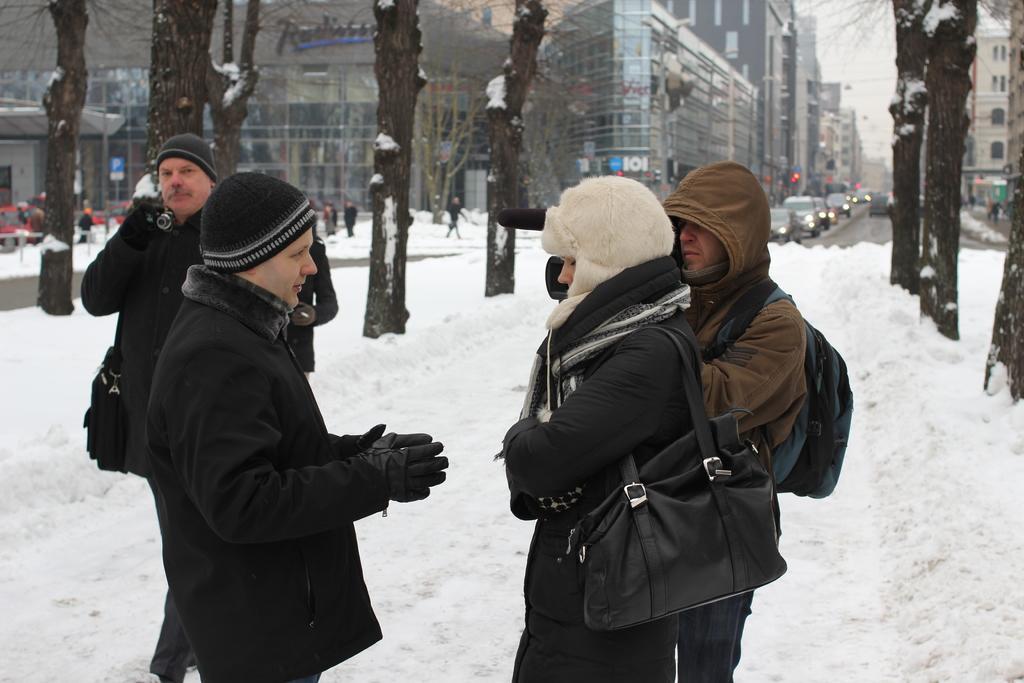Describe this image in one or two sentences. In this picture there are people in the center of the image and there is snow in the center of the image, there are buildings and trees in the background area of the image. 